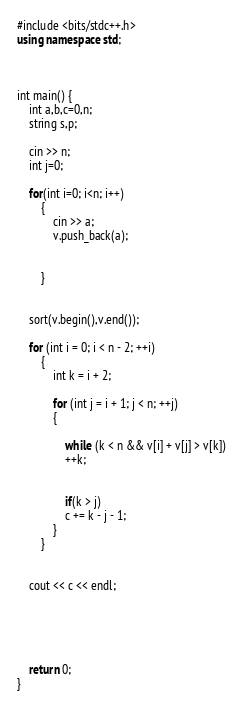<code> <loc_0><loc_0><loc_500><loc_500><_C++_>#include <bits/stdc++.h>
using namespace std;
  


int main() {
    int a,b,c=0,n;
    string s,p;
   
    cin >> n;
    int j=0;
    
    for(int i=0; i<n; i++)
        {
            cin >> a;
            v.push_back(a);
        
        
        }
    
  
    sort(v.begin(),v.end());
    
    for (int i = 0; i < n - 2; ++i)
        {
            int k = i + 2;

            for (int j = i + 1; j < n; ++j)
            {
               
                while (k < n && v[i] + v[j] > v[k])
                ++k;

              
                if(k > j)
                c += k - j - 1;
            }
        }

        
    cout << c << endl;

 
    
    
       
    return 0;
}</code> 